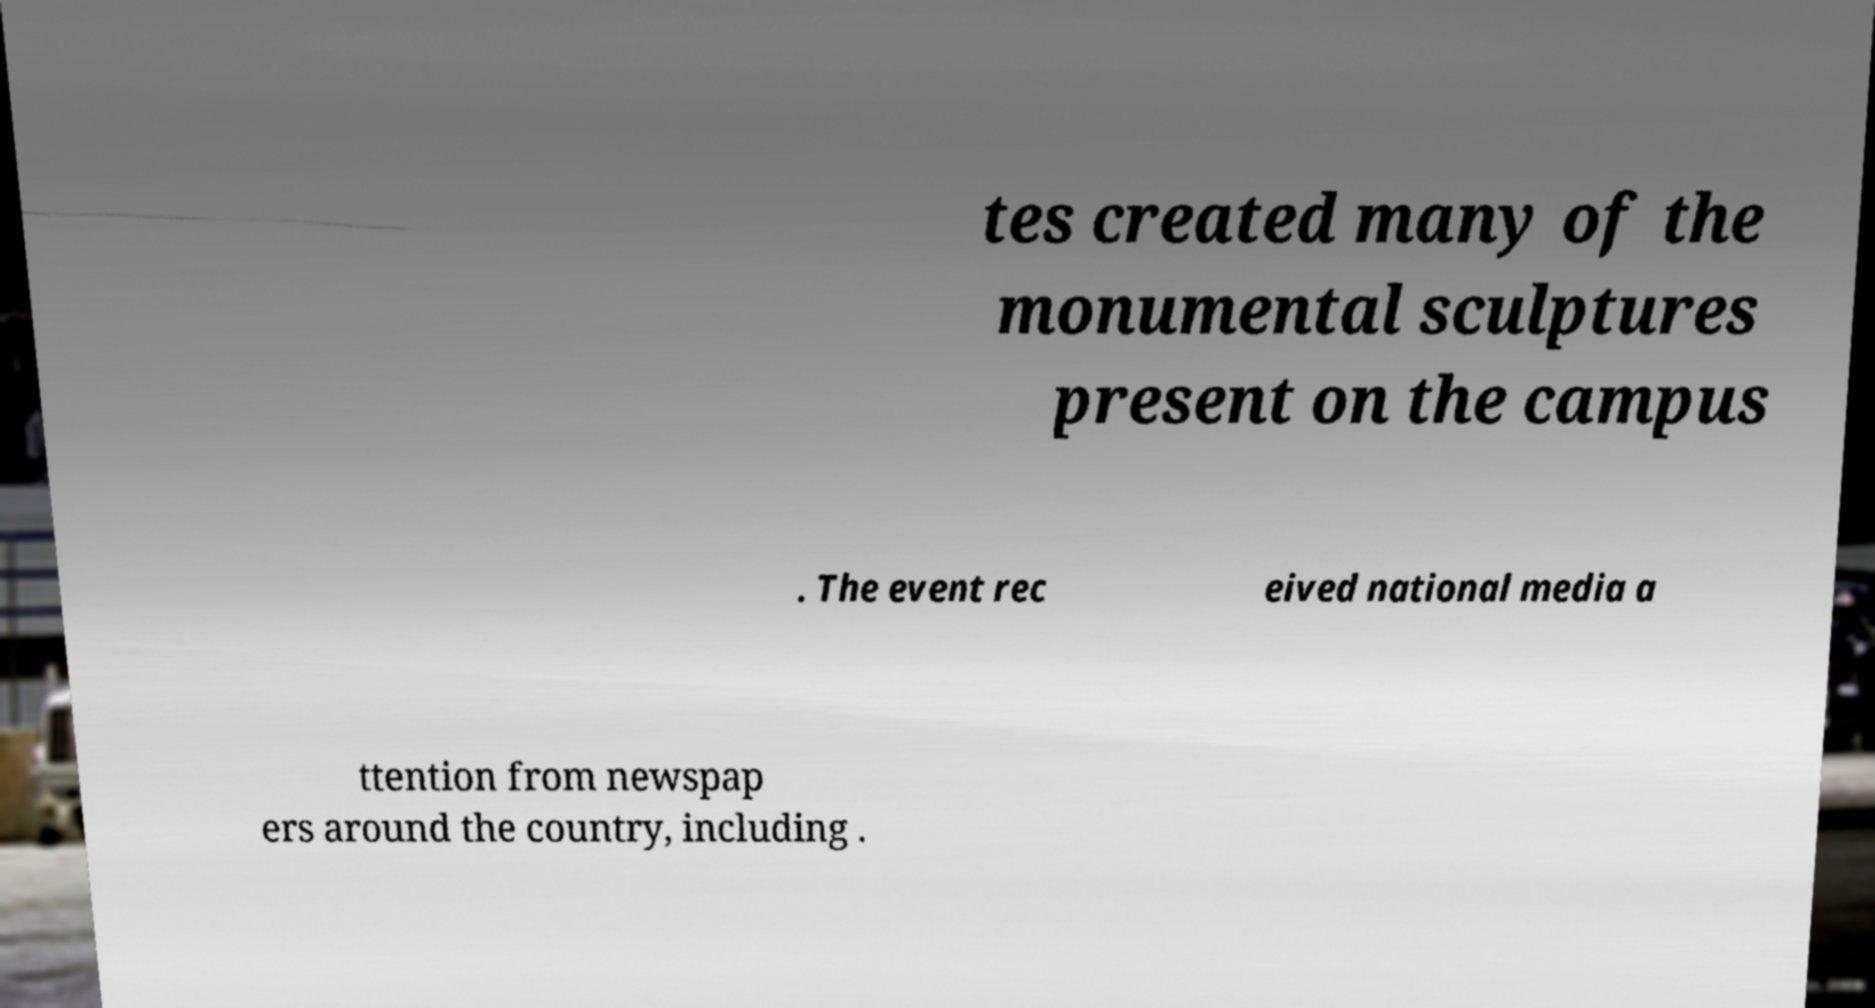Could you extract and type out the text from this image? tes created many of the monumental sculptures present on the campus . The event rec eived national media a ttention from newspap ers around the country, including . 